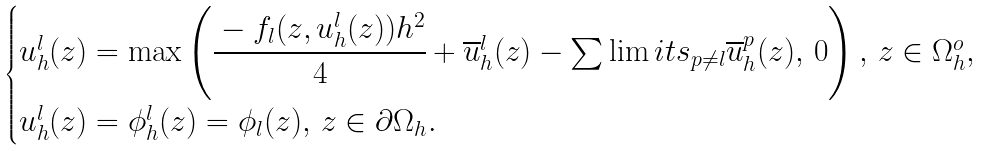<formula> <loc_0><loc_0><loc_500><loc_500>\begin{cases} u _ { h } ^ { l } ( z ) = \max \left ( \cfrac { - f _ { l } ( z , u _ { h } ^ { l } ( z ) ) h ^ { 2 } } { 4 } + \overline { u } _ { h } ^ { l } ( z ) - \sum \lim i t s _ { p \neq l } \overline { u } _ { h } ^ { p } ( z ) , \, 0 \right ) , \, z \in \Omega _ { h } ^ { o } , \\ u _ { h } ^ { l } ( z ) = \phi _ { h } ^ { l } ( z ) = \phi _ { l } ( z ) , \, z \in \partial \Omega _ { h } . \end{cases}</formula> 